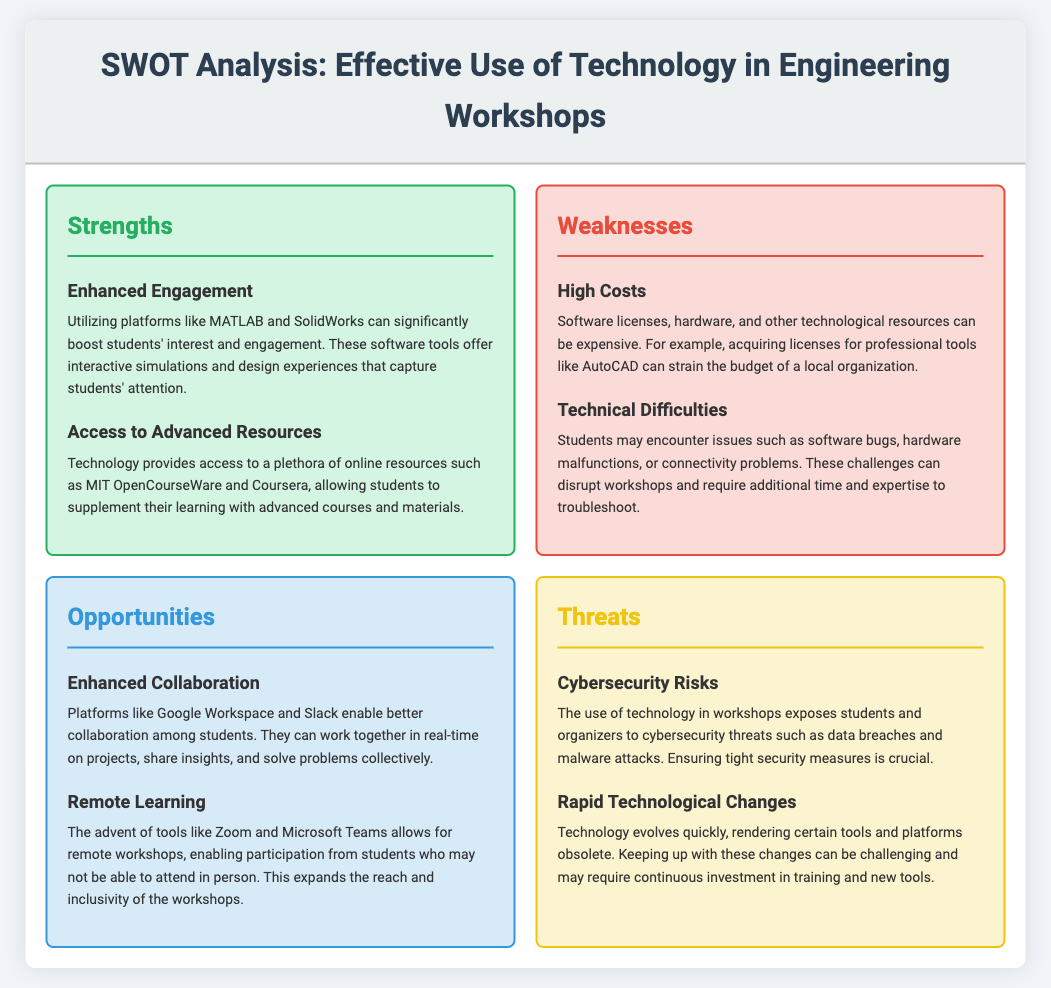what is one example of a software that enhances engagement? The document lists MATLAB as a software tool that significantly boosts students' interest and engagement in workshops.
Answer: MATLAB what are the names of two platforms that enable better collaboration? Google Workspace and Slack are mentioned as platforms that enable better collaboration among students.
Answer: Google Workspace and Slack what is a major weakness related to technology in workshops? The document discusses high costs as a major weakness concerning the expense of software licenses, hardware, and other resources.
Answer: High Costs what type of risks are associated with the use of technology in workshops? Cybersecurity risks such as data breaches and malware attacks are highlighted as threats in the document.
Answer: Cybersecurity Risks which tool allows for remote workshops? The document mentions Zoom as a tool that allows for remote workshops and expands participation.
Answer: Zoom what is a potential opportunity presented by technology? Enhanced collaboration among students through real-time project work is presented as an opportunity in the document.
Answer: Enhanced Collaboration what issue might disrupt workshops according to the document? Technical difficulties like software bugs and hardware malfunctions are mentioned as potential disruptors to workshops.
Answer: Technical Difficulties what is a challenge related to the rapid evolution of technology? The document states that keeping up with rapid technological changes can be challenging and require continuous investment.
Answer: Continuous investment which online resource is noted for offering advanced courses? MIT OpenCourseWare is listed as an example of an online resource that provides access to advanced courses.
Answer: MIT OpenCourseWare 